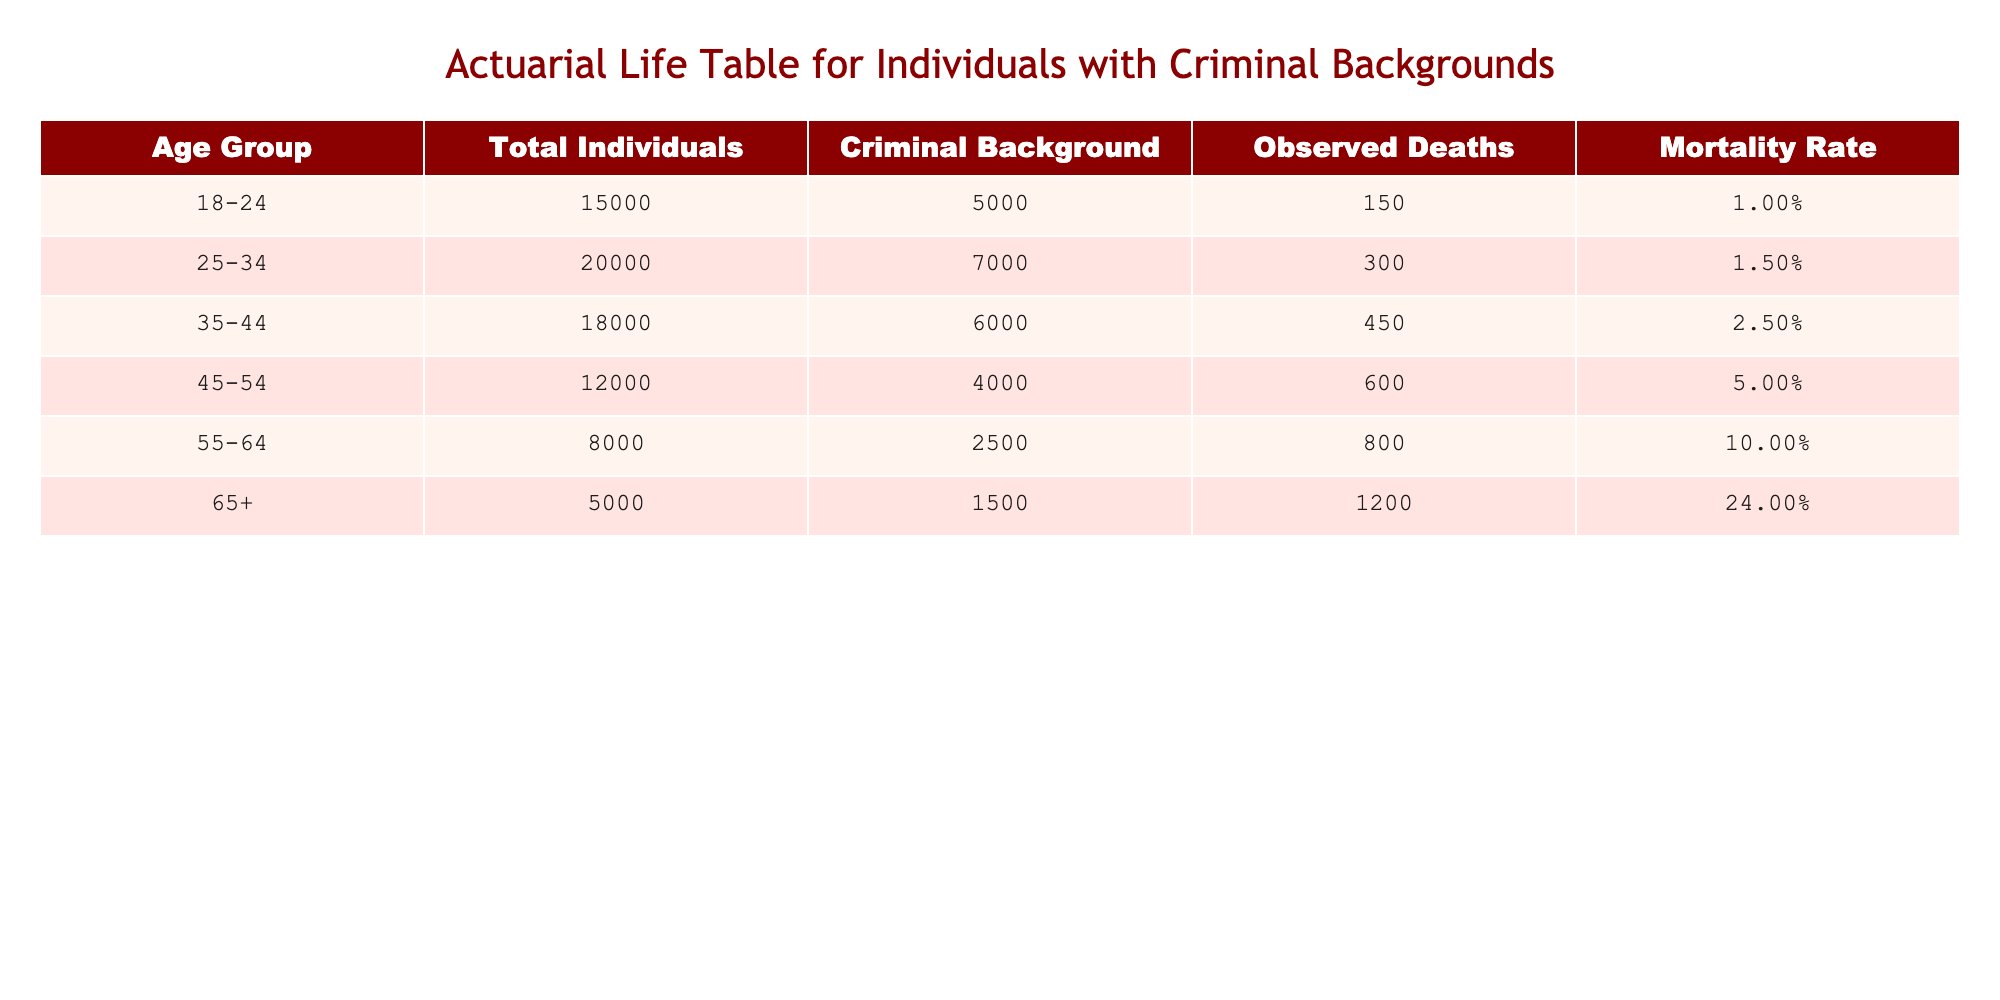What is the mortality rate for the age group 25-34? According to the table, the mortality rate for the age group 25-34 is explicitly stated in the row associated with this age group. It shows a mortality rate of 1.50%.
Answer: 1.50% Which age group has the highest number of observed deaths? The table lists observed deaths for each age group. By comparing these values, the age group 65+ has the highest observed deaths at 1200.
Answer: 65+ What is the total number of individuals with a criminal background in the age group 45-54? In the table, the number of individuals with a criminal background in the age group 45-54 is specifically given as 4000.
Answer: 4000 Are there more individuals in the age group 55-64 compared to those in the age group 35-44? To answer this question, we look at the total individuals for both age groups. 55-64 has 8000 individuals, while 35-44 has 18000 individuals. Therefore, there are fewer individuals in the 55-64 age group.
Answer: No What is the average mortality rate of all age groups combined? To find the average mortality rate, we sum the mortality rates (1.00% + 1.50% + 2.50% + 5.00% + 10.00% + 24.00% = 44.00%) and divide by the number of age groups (6). The average is 44.00% / 6 = 7.33%.
Answer: 7.33% Which age group shows a mortality rate higher than 5%? Looking through the mortality rates in the table, both the 55-64 age group (10.00%) and the 65+ age group (24.00%) exceed the 5% threshold.
Answer: 55-64, 65+ What is the difference in the number of observed deaths between the age groups 18-24 and 45-54? The observed deaths for the 18-24 age group are 150, while for the 45-54 group, they are 600. To find the difference, we subtract: 600 - 150 = 450.
Answer: 450 Is the number of individuals with a criminal background in the age group 18-24 less than 6000? The table indicates that the number of individuals with a criminal background in the age group 18-24 is 5000, which is indeed less than 6000.
Answer: Yes 